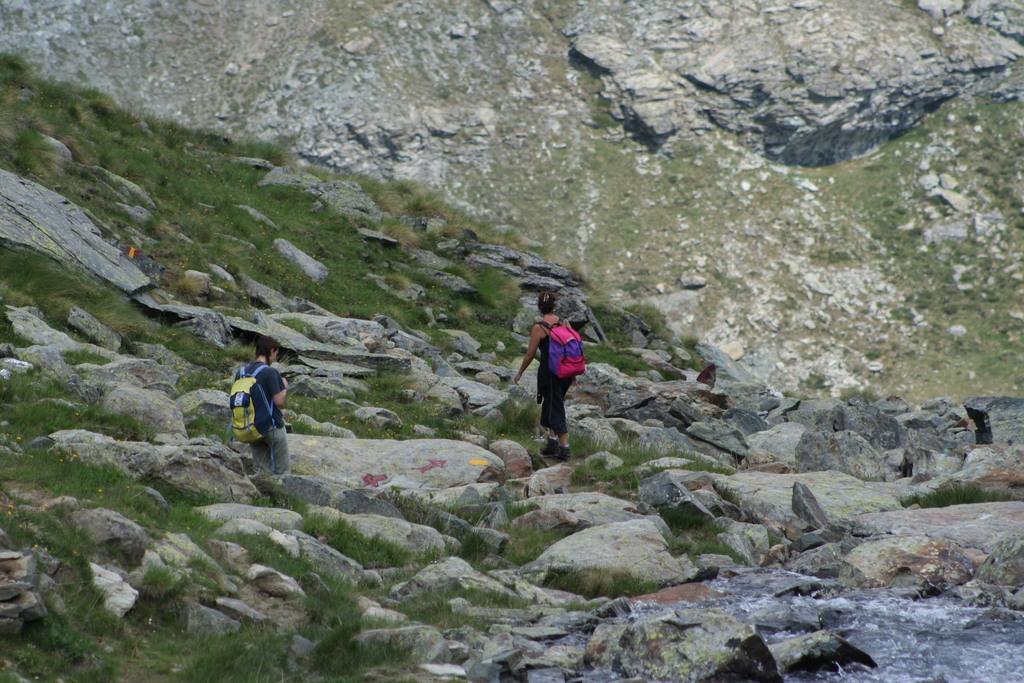Please provide a concise description of this image. In this picture I can observe two members. Both of them are carrying bags on their shoulders. There are some rocks. In the background there is a hill. 